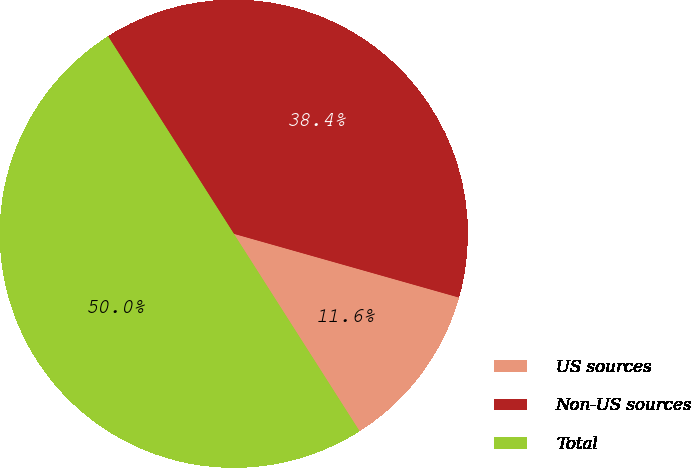<chart> <loc_0><loc_0><loc_500><loc_500><pie_chart><fcel>US sources<fcel>Non-US sources<fcel>Total<nl><fcel>11.58%<fcel>38.42%<fcel>50.0%<nl></chart> 